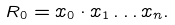Convert formula to latex. <formula><loc_0><loc_0><loc_500><loc_500>R _ { 0 } = x _ { 0 } \cdot x _ { 1 } \dots x _ { n } .</formula> 